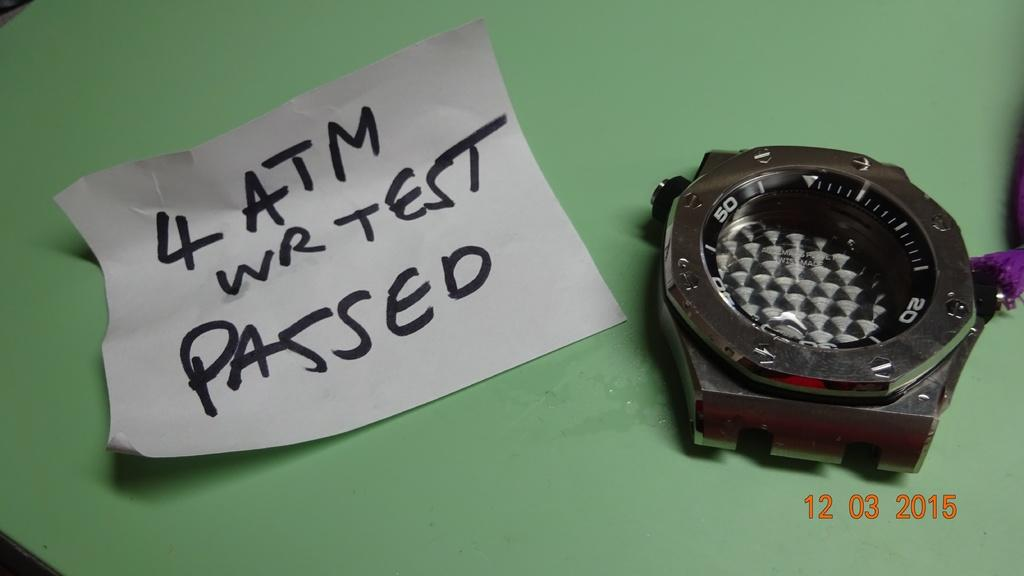<image>
Relay a brief, clear account of the picture shown. A watch face sits next to a note stating 4 ATM WR TEST PASSED. 